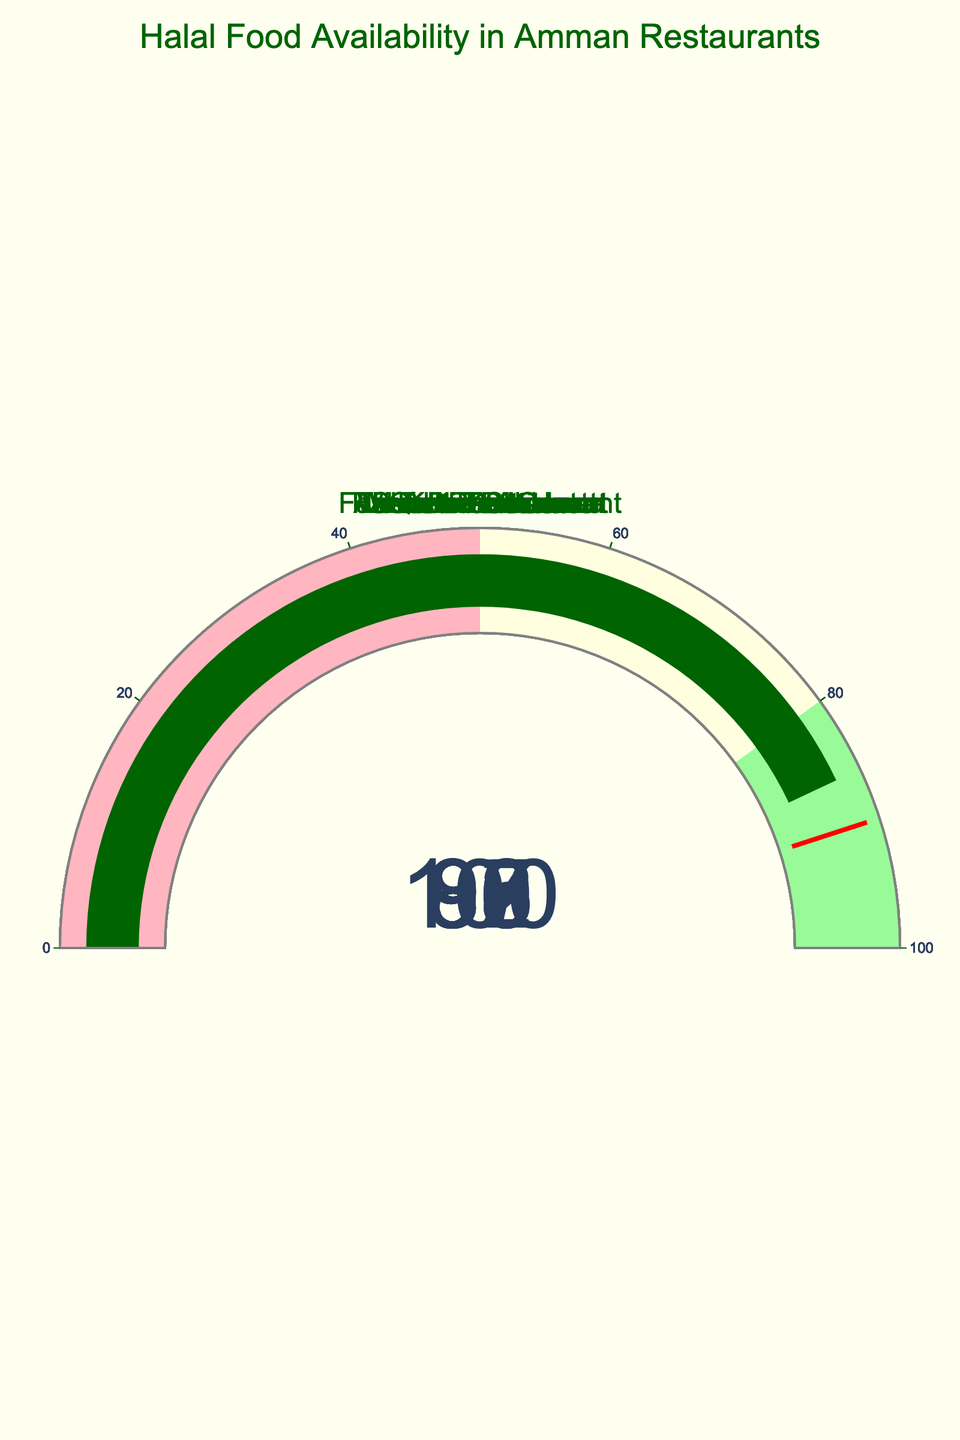What's the restaurant with the highest Halal availability? The gauge charts display the Halal availability percentages for each restaurant. The highest value displayed is 100% at Sufra Restaurant.
Answer: Sufra Restaurant What's the average Halal availability percentage for the restaurants? Add all the percentages and divide by the number of restaurants: (95+100+98+92+88+85+80+97+90+86)/10 = 91.1
Answer: 91.1 Which restaurant has the lowest Halal availability? The gauge chart with the lowest value shows 80%, which is Wild Jordan Center.
Answer: Wild Jordan Center How many restaurants have a Halal availability above 90%? Count the number of gauges showing a value greater than 90: Al-Quds Restaurant (95), Sufra Restaurant (100), Hashem Restaurant (98), Fakhreldin Restaurant (92), Tawaheen Al-Hawa (97). This gives us 5 restaurants.
Answer: 5 What's the difference in Halal availability between Sufra Restaurant and Wild Jordan Center? Subtract the value of Wild Jordan Center from Sufra Restaurant: 100 - 80 = 20
Answer: 20 Which restaurant's Halal availability is closest to 90%? Check the gauge values closest to 90: Rakwet Arab with 90% is the closest.
Answer: Rakwet Arab What's the median Halal availability percentage of the restaurants? Arrange percentages and find the middle value (or the average of the two middle values): 80, 85, 86, 88, 90, 92, 95, 97, 98, 100. Since there are 10 values, the median is (90 + 92)/2 = 91
Answer: 91 Which restaurants fall into the 'light pink' range of the gauge? The 'light pink' range is 0-50%. None of the restaurants fall in this range as all values are above 50%.
Answer: None How many restaurants have Halal availability between 80% and 90%? Count the number of gauges showing a value within this range: Levant Restaurant (88), Kan Zaman (85), Wild Jordan Center (80), Beit Sitti (86). This gives us 4 restaurants.
Answer: 4 